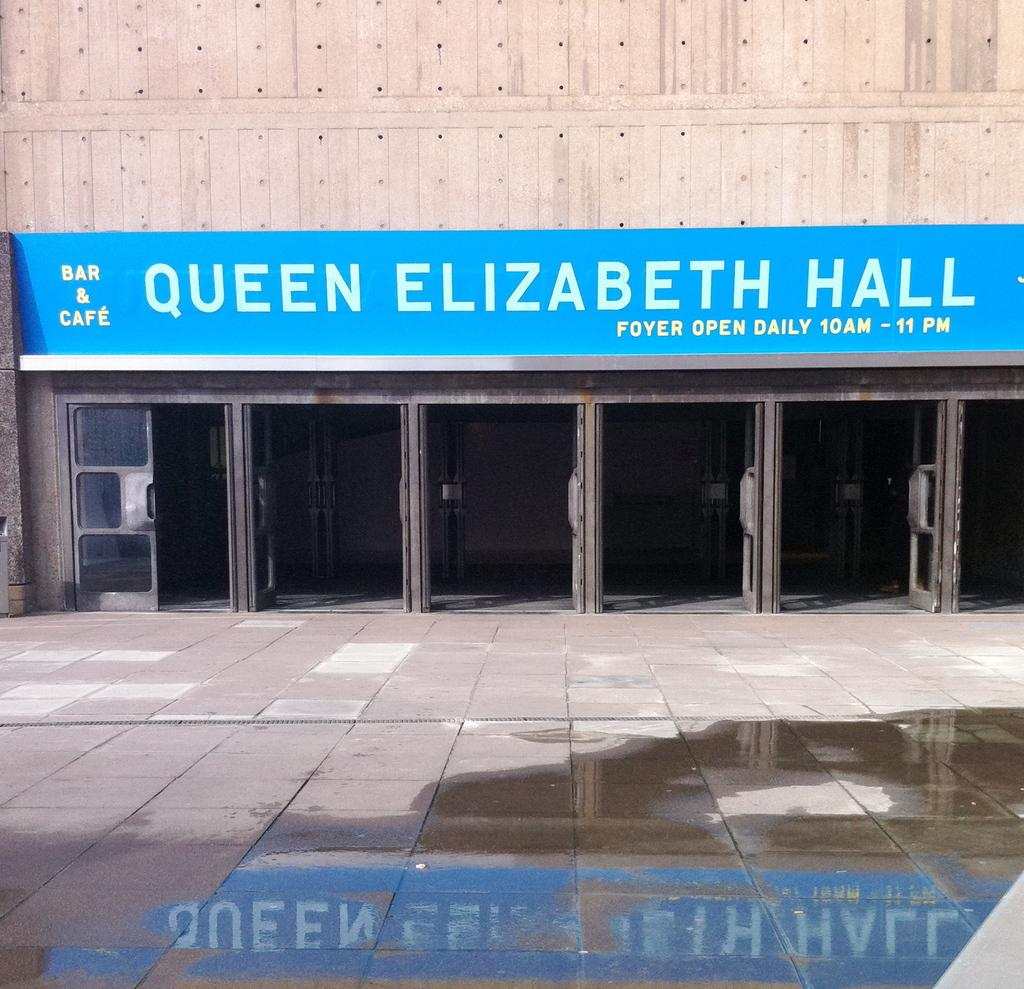What color is the hoarding on the wall in the image? The hoarding on the wall is blue. What type of openings can be seen in the image? There are doors in the image. What is present on a surface in the image? There is water on a surface in the image. What type of frame is around the water in the image? There is no frame around the water in the image; it is simply present on a surface. 